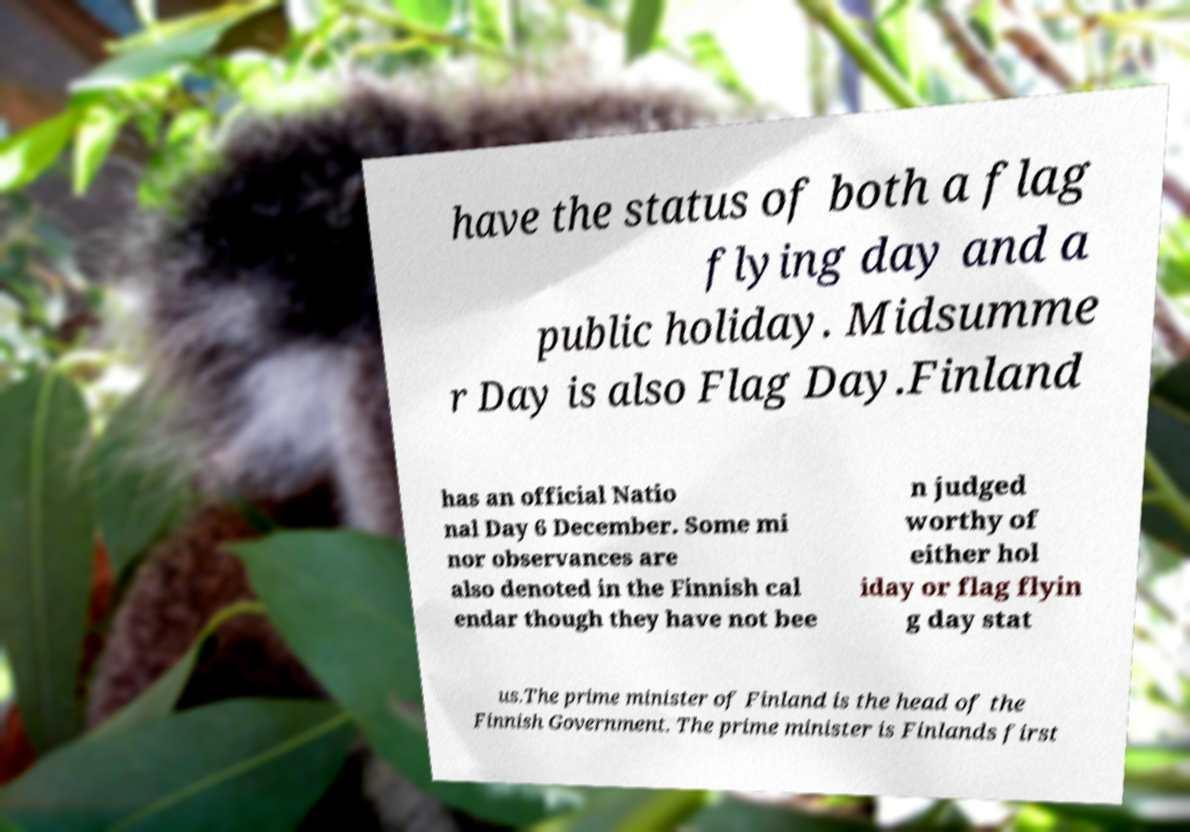There's text embedded in this image that I need extracted. Can you transcribe it verbatim? have the status of both a flag flying day and a public holiday. Midsumme r Day is also Flag Day.Finland has an official Natio nal Day 6 December. Some mi nor observances are also denoted in the Finnish cal endar though they have not bee n judged worthy of either hol iday or flag flyin g day stat us.The prime minister of Finland is the head of the Finnish Government. The prime minister is Finlands first 